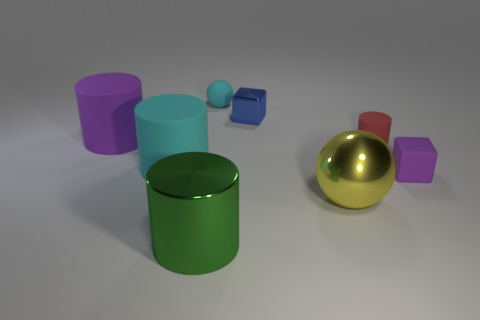There is a big rubber thing that is the same color as the tiny matte ball; what shape is it?
Give a very brief answer. Cylinder. There is a green thing that is to the right of the large cyan thing; is it the same size as the purple rubber thing to the right of the green metallic cylinder?
Your response must be concise. No. There is a large cylinder that is in front of the red rubber cylinder and behind the green metal object; what material is it made of?
Your answer should be compact. Rubber. Are there any other things of the same color as the rubber ball?
Keep it short and to the point. Yes. Are there fewer tiny blue metal things that are behind the shiny ball than cyan matte things?
Provide a succinct answer. Yes. Is the number of brown matte things greater than the number of large matte cylinders?
Ensure brevity in your answer.  No. Is there a small metallic block that is on the right side of the purple thing that is right of the block that is on the left side of the purple cube?
Keep it short and to the point. No. How many other things are there of the same size as the blue block?
Ensure brevity in your answer.  3. There is a large sphere; are there any objects behind it?
Provide a succinct answer. Yes. There is a matte sphere; does it have the same color as the large rubber cylinder in front of the large purple matte object?
Ensure brevity in your answer.  Yes. 